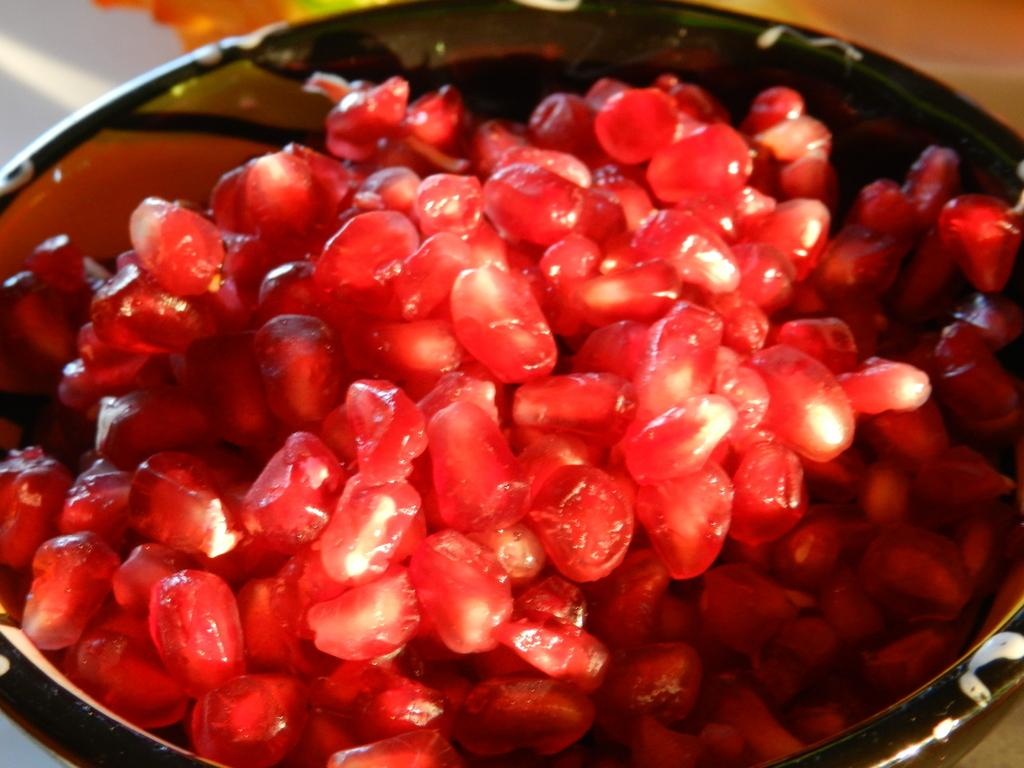What color are the seeds visible in the image? The seeds are red in color. What type of fruit might these seeds belong to? The seeds are from a fruit, but the specific fruit cannot be determined from the image alone. Where are the seeds located in the image? The seeds are on a plate. How does the distribution of the seeds on the plate affect the braking system of a vehicle in the image? There is no vehicle or braking system present in the image, so this question is not relevant to the image. 